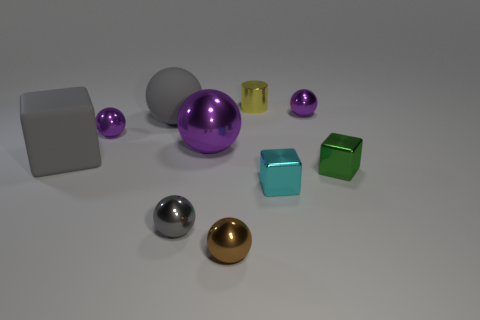Subtract all brown cylinders. How many purple balls are left? 3 Subtract all brown balls. How many balls are left? 5 Subtract all large balls. How many balls are left? 4 Subtract all blue balls. Subtract all red cylinders. How many balls are left? 6 Subtract all cubes. How many objects are left? 7 Add 3 big metallic balls. How many big metallic balls exist? 4 Subtract 0 blue spheres. How many objects are left? 10 Subtract all tiny blue matte cubes. Subtract all tiny brown shiny things. How many objects are left? 9 Add 4 large purple balls. How many large purple balls are left? 5 